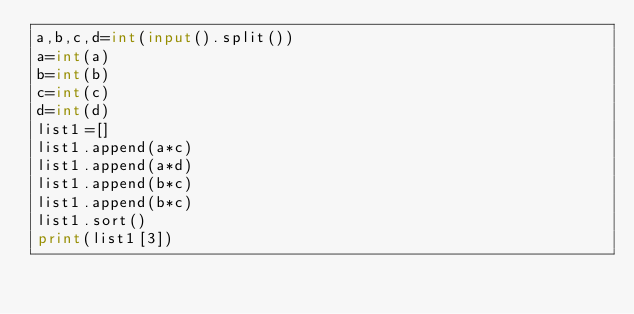Convert code to text. <code><loc_0><loc_0><loc_500><loc_500><_Python_>a,b,c,d=int(input().split())
a=int(a)
b=int(b)
c=int(c)
d=int(d)
list1=[]
list1.append(a*c)
list1.append(a*d)
list1.append(b*c)
list1.append(b*c)
list1.sort()
print(list1[3])</code> 